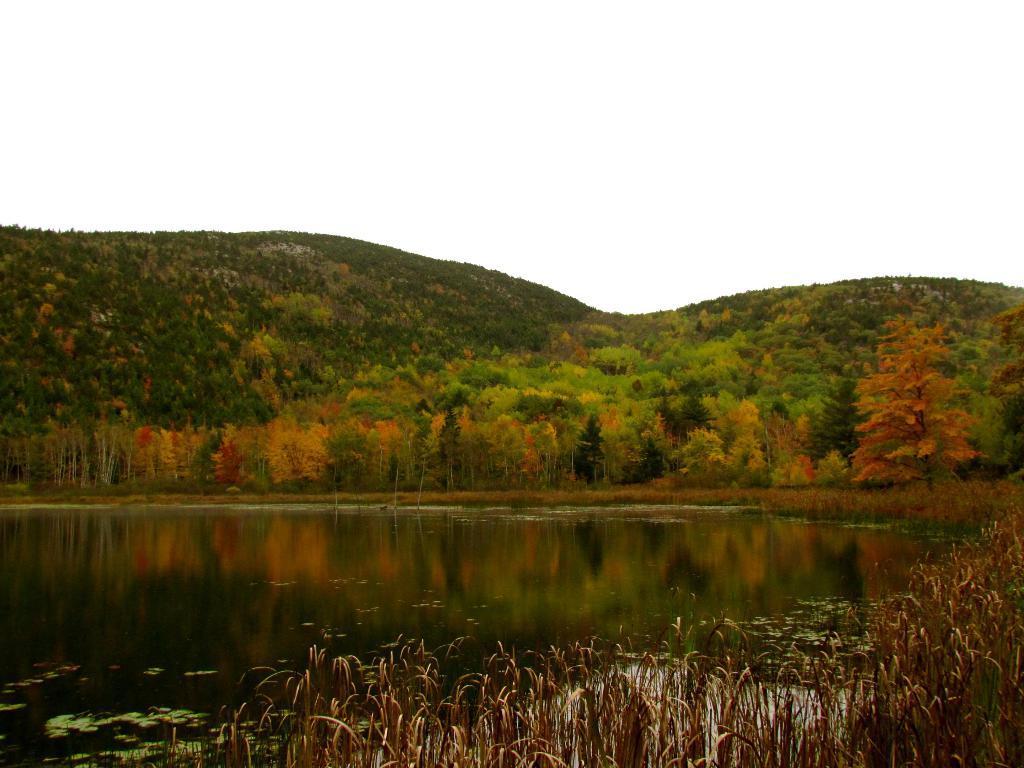Please provide a concise description of this image. In this image, we can see trees and hills and at the bottom, there is water and some plants. At the top, there is sky. 